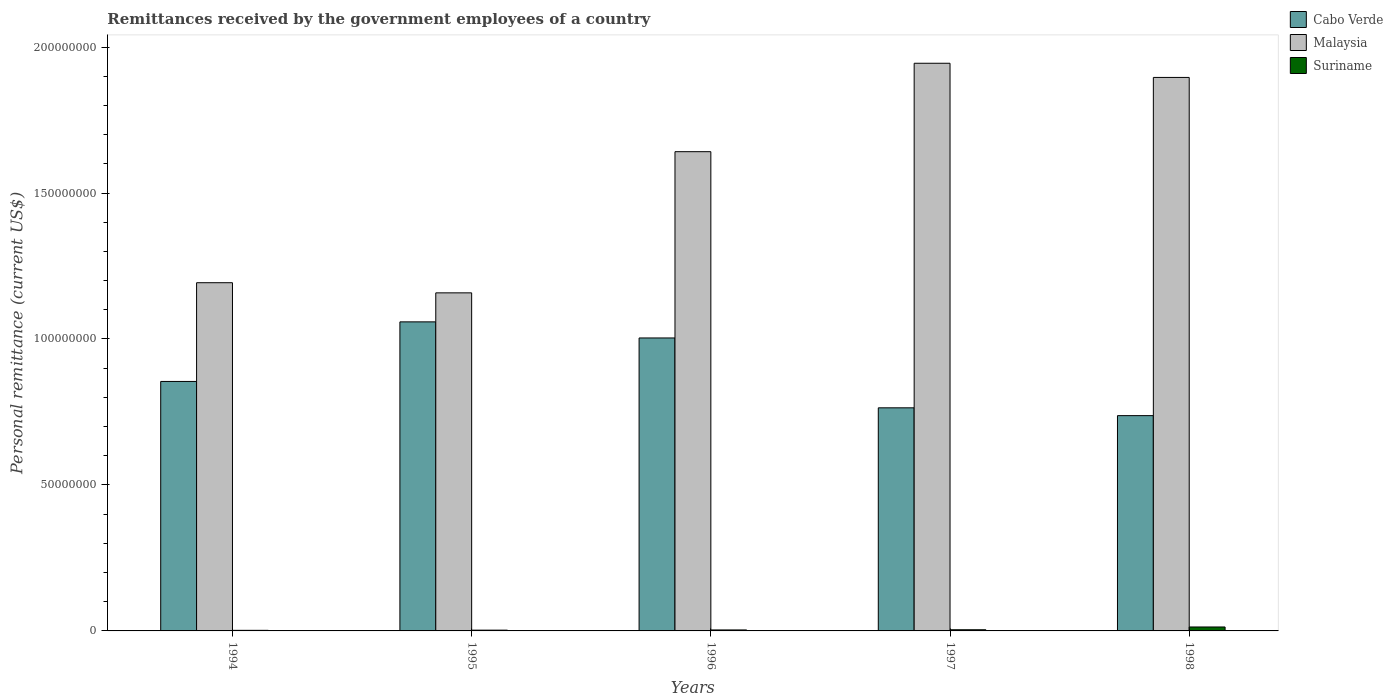How many different coloured bars are there?
Ensure brevity in your answer.  3. How many groups of bars are there?
Offer a terse response. 5. Are the number of bars per tick equal to the number of legend labels?
Provide a succinct answer. Yes. How many bars are there on the 4th tick from the right?
Your answer should be very brief. 3. What is the label of the 1st group of bars from the left?
Provide a succinct answer. 1994. In how many cases, is the number of bars for a given year not equal to the number of legend labels?
Offer a very short reply. 0. What is the remittances received by the government employees in Malaysia in 1994?
Give a very brief answer. 1.19e+08. Across all years, what is the maximum remittances received by the government employees in Malaysia?
Keep it short and to the point. 1.94e+08. Across all years, what is the minimum remittances received by the government employees in Malaysia?
Provide a succinct answer. 1.16e+08. In which year was the remittances received by the government employees in Suriname minimum?
Keep it short and to the point. 1994. What is the total remittances received by the government employees in Malaysia in the graph?
Offer a very short reply. 7.83e+08. What is the difference between the remittances received by the government employees in Cabo Verde in 1997 and that in 1998?
Provide a succinct answer. 2.68e+06. What is the difference between the remittances received by the government employees in Malaysia in 1994 and the remittances received by the government employees in Suriname in 1995?
Your answer should be very brief. 1.19e+08. What is the average remittances received by the government employees in Cabo Verde per year?
Ensure brevity in your answer.  8.84e+07. In the year 1997, what is the difference between the remittances received by the government employees in Suriname and remittances received by the government employees in Malaysia?
Keep it short and to the point. -1.94e+08. What is the ratio of the remittances received by the government employees in Cabo Verde in 1994 to that in 1995?
Give a very brief answer. 0.81. What is the difference between the highest and the second highest remittances received by the government employees in Malaysia?
Provide a succinct answer. 4.86e+06. What is the difference between the highest and the lowest remittances received by the government employees in Cabo Verde?
Provide a short and direct response. 3.21e+07. Is the sum of the remittances received by the government employees in Malaysia in 1994 and 1998 greater than the maximum remittances received by the government employees in Suriname across all years?
Ensure brevity in your answer.  Yes. What does the 2nd bar from the left in 1998 represents?
Keep it short and to the point. Malaysia. What does the 3rd bar from the right in 1997 represents?
Ensure brevity in your answer.  Cabo Verde. Is it the case that in every year, the sum of the remittances received by the government employees in Suriname and remittances received by the government employees in Malaysia is greater than the remittances received by the government employees in Cabo Verde?
Ensure brevity in your answer.  Yes. How many bars are there?
Offer a very short reply. 15. Are all the bars in the graph horizontal?
Ensure brevity in your answer.  No. How many years are there in the graph?
Offer a very short reply. 5. What is the difference between two consecutive major ticks on the Y-axis?
Provide a short and direct response. 5.00e+07. Are the values on the major ticks of Y-axis written in scientific E-notation?
Your answer should be compact. No. Does the graph contain any zero values?
Your answer should be very brief. No. How many legend labels are there?
Ensure brevity in your answer.  3. How are the legend labels stacked?
Your answer should be very brief. Vertical. What is the title of the graph?
Give a very brief answer. Remittances received by the government employees of a country. What is the label or title of the Y-axis?
Make the answer very short. Personal remittance (current US$). What is the Personal remittance (current US$) of Cabo Verde in 1994?
Your answer should be very brief. 8.55e+07. What is the Personal remittance (current US$) of Malaysia in 1994?
Your answer should be very brief. 1.19e+08. What is the Personal remittance (current US$) of Suriname in 1994?
Your response must be concise. 2.00e+05. What is the Personal remittance (current US$) of Cabo Verde in 1995?
Ensure brevity in your answer.  1.06e+08. What is the Personal remittance (current US$) of Malaysia in 1995?
Your answer should be compact. 1.16e+08. What is the Personal remittance (current US$) of Suriname in 1995?
Offer a very short reply. 2.67e+05. What is the Personal remittance (current US$) of Cabo Verde in 1996?
Offer a terse response. 1.00e+08. What is the Personal remittance (current US$) in Malaysia in 1996?
Offer a very short reply. 1.64e+08. What is the Personal remittance (current US$) of Suriname in 1996?
Offer a terse response. 3.33e+05. What is the Personal remittance (current US$) of Cabo Verde in 1997?
Ensure brevity in your answer.  7.64e+07. What is the Personal remittance (current US$) of Malaysia in 1997?
Your answer should be compact. 1.94e+08. What is the Personal remittance (current US$) in Suriname in 1997?
Make the answer very short. 4.00e+05. What is the Personal remittance (current US$) of Cabo Verde in 1998?
Provide a short and direct response. 7.37e+07. What is the Personal remittance (current US$) of Malaysia in 1998?
Give a very brief answer. 1.90e+08. What is the Personal remittance (current US$) in Suriname in 1998?
Provide a succinct answer. 1.35e+06. Across all years, what is the maximum Personal remittance (current US$) of Cabo Verde?
Offer a terse response. 1.06e+08. Across all years, what is the maximum Personal remittance (current US$) of Malaysia?
Provide a succinct answer. 1.94e+08. Across all years, what is the maximum Personal remittance (current US$) of Suriname?
Provide a short and direct response. 1.35e+06. Across all years, what is the minimum Personal remittance (current US$) of Cabo Verde?
Your answer should be compact. 7.37e+07. Across all years, what is the minimum Personal remittance (current US$) in Malaysia?
Provide a short and direct response. 1.16e+08. Across all years, what is the minimum Personal remittance (current US$) in Suriname?
Offer a very short reply. 2.00e+05. What is the total Personal remittance (current US$) of Cabo Verde in the graph?
Make the answer very short. 4.42e+08. What is the total Personal remittance (current US$) of Malaysia in the graph?
Offer a very short reply. 7.83e+08. What is the total Personal remittance (current US$) of Suriname in the graph?
Your response must be concise. 2.55e+06. What is the difference between the Personal remittance (current US$) of Cabo Verde in 1994 and that in 1995?
Give a very brief answer. -2.04e+07. What is the difference between the Personal remittance (current US$) in Malaysia in 1994 and that in 1995?
Keep it short and to the point. 3.48e+06. What is the difference between the Personal remittance (current US$) of Suriname in 1994 and that in 1995?
Keep it short and to the point. -6.67e+04. What is the difference between the Personal remittance (current US$) in Cabo Verde in 1994 and that in 1996?
Offer a very short reply. -1.49e+07. What is the difference between the Personal remittance (current US$) of Malaysia in 1994 and that in 1996?
Make the answer very short. -4.49e+07. What is the difference between the Personal remittance (current US$) in Suriname in 1994 and that in 1996?
Provide a succinct answer. -1.33e+05. What is the difference between the Personal remittance (current US$) of Cabo Verde in 1994 and that in 1997?
Provide a succinct answer. 9.04e+06. What is the difference between the Personal remittance (current US$) in Malaysia in 1994 and that in 1997?
Ensure brevity in your answer.  -7.52e+07. What is the difference between the Personal remittance (current US$) of Suriname in 1994 and that in 1997?
Provide a succinct answer. -2.00e+05. What is the difference between the Personal remittance (current US$) in Cabo Verde in 1994 and that in 1998?
Your answer should be very brief. 1.17e+07. What is the difference between the Personal remittance (current US$) in Malaysia in 1994 and that in 1998?
Give a very brief answer. -7.03e+07. What is the difference between the Personal remittance (current US$) in Suriname in 1994 and that in 1998?
Provide a succinct answer. -1.15e+06. What is the difference between the Personal remittance (current US$) of Cabo Verde in 1995 and that in 1996?
Your answer should be compact. 5.51e+06. What is the difference between the Personal remittance (current US$) in Malaysia in 1995 and that in 1996?
Provide a succinct answer. -4.84e+07. What is the difference between the Personal remittance (current US$) in Suriname in 1995 and that in 1996?
Your answer should be compact. -6.67e+04. What is the difference between the Personal remittance (current US$) in Cabo Verde in 1995 and that in 1997?
Provide a succinct answer. 2.94e+07. What is the difference between the Personal remittance (current US$) in Malaysia in 1995 and that in 1997?
Offer a terse response. -7.86e+07. What is the difference between the Personal remittance (current US$) of Suriname in 1995 and that in 1997?
Provide a succinct answer. -1.33e+05. What is the difference between the Personal remittance (current US$) of Cabo Verde in 1995 and that in 1998?
Your response must be concise. 3.21e+07. What is the difference between the Personal remittance (current US$) of Malaysia in 1995 and that in 1998?
Provide a succinct answer. -7.38e+07. What is the difference between the Personal remittance (current US$) of Suriname in 1995 and that in 1998?
Keep it short and to the point. -1.08e+06. What is the difference between the Personal remittance (current US$) in Cabo Verde in 1996 and that in 1997?
Your response must be concise. 2.39e+07. What is the difference between the Personal remittance (current US$) in Malaysia in 1996 and that in 1997?
Give a very brief answer. -3.03e+07. What is the difference between the Personal remittance (current US$) in Suriname in 1996 and that in 1997?
Your answer should be compact. -6.67e+04. What is the difference between the Personal remittance (current US$) of Cabo Verde in 1996 and that in 1998?
Provide a succinct answer. 2.66e+07. What is the difference between the Personal remittance (current US$) of Malaysia in 1996 and that in 1998?
Make the answer very short. -2.54e+07. What is the difference between the Personal remittance (current US$) in Suriname in 1996 and that in 1998?
Provide a succinct answer. -1.02e+06. What is the difference between the Personal remittance (current US$) in Cabo Verde in 1997 and that in 1998?
Offer a terse response. 2.68e+06. What is the difference between the Personal remittance (current US$) of Malaysia in 1997 and that in 1998?
Ensure brevity in your answer.  4.86e+06. What is the difference between the Personal remittance (current US$) in Suriname in 1997 and that in 1998?
Give a very brief answer. -9.50e+05. What is the difference between the Personal remittance (current US$) of Cabo Verde in 1994 and the Personal remittance (current US$) of Malaysia in 1995?
Provide a short and direct response. -3.03e+07. What is the difference between the Personal remittance (current US$) in Cabo Verde in 1994 and the Personal remittance (current US$) in Suriname in 1995?
Ensure brevity in your answer.  8.52e+07. What is the difference between the Personal remittance (current US$) of Malaysia in 1994 and the Personal remittance (current US$) of Suriname in 1995?
Keep it short and to the point. 1.19e+08. What is the difference between the Personal remittance (current US$) of Cabo Verde in 1994 and the Personal remittance (current US$) of Malaysia in 1996?
Ensure brevity in your answer.  -7.87e+07. What is the difference between the Personal remittance (current US$) of Cabo Verde in 1994 and the Personal remittance (current US$) of Suriname in 1996?
Your answer should be compact. 8.51e+07. What is the difference between the Personal remittance (current US$) of Malaysia in 1994 and the Personal remittance (current US$) of Suriname in 1996?
Your answer should be compact. 1.19e+08. What is the difference between the Personal remittance (current US$) of Cabo Verde in 1994 and the Personal remittance (current US$) of Malaysia in 1997?
Your response must be concise. -1.09e+08. What is the difference between the Personal remittance (current US$) of Cabo Verde in 1994 and the Personal remittance (current US$) of Suriname in 1997?
Your response must be concise. 8.51e+07. What is the difference between the Personal remittance (current US$) of Malaysia in 1994 and the Personal remittance (current US$) of Suriname in 1997?
Make the answer very short. 1.19e+08. What is the difference between the Personal remittance (current US$) of Cabo Verde in 1994 and the Personal remittance (current US$) of Malaysia in 1998?
Ensure brevity in your answer.  -1.04e+08. What is the difference between the Personal remittance (current US$) of Cabo Verde in 1994 and the Personal remittance (current US$) of Suriname in 1998?
Keep it short and to the point. 8.41e+07. What is the difference between the Personal remittance (current US$) of Malaysia in 1994 and the Personal remittance (current US$) of Suriname in 1998?
Provide a short and direct response. 1.18e+08. What is the difference between the Personal remittance (current US$) in Cabo Verde in 1995 and the Personal remittance (current US$) in Malaysia in 1996?
Your answer should be very brief. -5.83e+07. What is the difference between the Personal remittance (current US$) of Cabo Verde in 1995 and the Personal remittance (current US$) of Suriname in 1996?
Your response must be concise. 1.06e+08. What is the difference between the Personal remittance (current US$) in Malaysia in 1995 and the Personal remittance (current US$) in Suriname in 1996?
Ensure brevity in your answer.  1.15e+08. What is the difference between the Personal remittance (current US$) of Cabo Verde in 1995 and the Personal remittance (current US$) of Malaysia in 1997?
Offer a terse response. -8.86e+07. What is the difference between the Personal remittance (current US$) in Cabo Verde in 1995 and the Personal remittance (current US$) in Suriname in 1997?
Offer a very short reply. 1.05e+08. What is the difference between the Personal remittance (current US$) of Malaysia in 1995 and the Personal remittance (current US$) of Suriname in 1997?
Keep it short and to the point. 1.15e+08. What is the difference between the Personal remittance (current US$) of Cabo Verde in 1995 and the Personal remittance (current US$) of Malaysia in 1998?
Your response must be concise. -8.37e+07. What is the difference between the Personal remittance (current US$) of Cabo Verde in 1995 and the Personal remittance (current US$) of Suriname in 1998?
Your answer should be very brief. 1.05e+08. What is the difference between the Personal remittance (current US$) of Malaysia in 1995 and the Personal remittance (current US$) of Suriname in 1998?
Your response must be concise. 1.14e+08. What is the difference between the Personal remittance (current US$) of Cabo Verde in 1996 and the Personal remittance (current US$) of Malaysia in 1997?
Your answer should be compact. -9.41e+07. What is the difference between the Personal remittance (current US$) of Cabo Verde in 1996 and the Personal remittance (current US$) of Suriname in 1997?
Offer a very short reply. 9.99e+07. What is the difference between the Personal remittance (current US$) of Malaysia in 1996 and the Personal remittance (current US$) of Suriname in 1997?
Provide a succinct answer. 1.64e+08. What is the difference between the Personal remittance (current US$) of Cabo Verde in 1996 and the Personal remittance (current US$) of Malaysia in 1998?
Ensure brevity in your answer.  -8.92e+07. What is the difference between the Personal remittance (current US$) in Cabo Verde in 1996 and the Personal remittance (current US$) in Suriname in 1998?
Offer a very short reply. 9.90e+07. What is the difference between the Personal remittance (current US$) in Malaysia in 1996 and the Personal remittance (current US$) in Suriname in 1998?
Ensure brevity in your answer.  1.63e+08. What is the difference between the Personal remittance (current US$) of Cabo Verde in 1997 and the Personal remittance (current US$) of Malaysia in 1998?
Make the answer very short. -1.13e+08. What is the difference between the Personal remittance (current US$) of Cabo Verde in 1997 and the Personal remittance (current US$) of Suriname in 1998?
Ensure brevity in your answer.  7.51e+07. What is the difference between the Personal remittance (current US$) of Malaysia in 1997 and the Personal remittance (current US$) of Suriname in 1998?
Provide a succinct answer. 1.93e+08. What is the average Personal remittance (current US$) of Cabo Verde per year?
Your response must be concise. 8.84e+07. What is the average Personal remittance (current US$) of Malaysia per year?
Your response must be concise. 1.57e+08. What is the average Personal remittance (current US$) in Suriname per year?
Offer a very short reply. 5.10e+05. In the year 1994, what is the difference between the Personal remittance (current US$) of Cabo Verde and Personal remittance (current US$) of Malaysia?
Ensure brevity in your answer.  -3.38e+07. In the year 1994, what is the difference between the Personal remittance (current US$) in Cabo Verde and Personal remittance (current US$) in Suriname?
Keep it short and to the point. 8.53e+07. In the year 1994, what is the difference between the Personal remittance (current US$) in Malaysia and Personal remittance (current US$) in Suriname?
Keep it short and to the point. 1.19e+08. In the year 1995, what is the difference between the Personal remittance (current US$) in Cabo Verde and Personal remittance (current US$) in Malaysia?
Your answer should be very brief. -9.94e+06. In the year 1995, what is the difference between the Personal remittance (current US$) of Cabo Verde and Personal remittance (current US$) of Suriname?
Provide a succinct answer. 1.06e+08. In the year 1995, what is the difference between the Personal remittance (current US$) of Malaysia and Personal remittance (current US$) of Suriname?
Keep it short and to the point. 1.16e+08. In the year 1996, what is the difference between the Personal remittance (current US$) of Cabo Verde and Personal remittance (current US$) of Malaysia?
Your response must be concise. -6.38e+07. In the year 1996, what is the difference between the Personal remittance (current US$) of Cabo Verde and Personal remittance (current US$) of Suriname?
Your response must be concise. 1.00e+08. In the year 1996, what is the difference between the Personal remittance (current US$) of Malaysia and Personal remittance (current US$) of Suriname?
Ensure brevity in your answer.  1.64e+08. In the year 1997, what is the difference between the Personal remittance (current US$) of Cabo Verde and Personal remittance (current US$) of Malaysia?
Make the answer very short. -1.18e+08. In the year 1997, what is the difference between the Personal remittance (current US$) in Cabo Verde and Personal remittance (current US$) in Suriname?
Provide a succinct answer. 7.60e+07. In the year 1997, what is the difference between the Personal remittance (current US$) of Malaysia and Personal remittance (current US$) of Suriname?
Offer a very short reply. 1.94e+08. In the year 1998, what is the difference between the Personal remittance (current US$) of Cabo Verde and Personal remittance (current US$) of Malaysia?
Provide a succinct answer. -1.16e+08. In the year 1998, what is the difference between the Personal remittance (current US$) of Cabo Verde and Personal remittance (current US$) of Suriname?
Ensure brevity in your answer.  7.24e+07. In the year 1998, what is the difference between the Personal remittance (current US$) of Malaysia and Personal remittance (current US$) of Suriname?
Keep it short and to the point. 1.88e+08. What is the ratio of the Personal remittance (current US$) in Cabo Verde in 1994 to that in 1995?
Provide a short and direct response. 0.81. What is the ratio of the Personal remittance (current US$) of Suriname in 1994 to that in 1995?
Offer a very short reply. 0.75. What is the ratio of the Personal remittance (current US$) of Cabo Verde in 1994 to that in 1996?
Ensure brevity in your answer.  0.85. What is the ratio of the Personal remittance (current US$) in Malaysia in 1994 to that in 1996?
Provide a short and direct response. 0.73. What is the ratio of the Personal remittance (current US$) of Cabo Verde in 1994 to that in 1997?
Offer a very short reply. 1.12. What is the ratio of the Personal remittance (current US$) of Malaysia in 1994 to that in 1997?
Make the answer very short. 0.61. What is the ratio of the Personal remittance (current US$) of Cabo Verde in 1994 to that in 1998?
Offer a terse response. 1.16. What is the ratio of the Personal remittance (current US$) of Malaysia in 1994 to that in 1998?
Keep it short and to the point. 0.63. What is the ratio of the Personal remittance (current US$) in Suriname in 1994 to that in 1998?
Ensure brevity in your answer.  0.15. What is the ratio of the Personal remittance (current US$) in Cabo Verde in 1995 to that in 1996?
Offer a very short reply. 1.05. What is the ratio of the Personal remittance (current US$) of Malaysia in 1995 to that in 1996?
Offer a terse response. 0.71. What is the ratio of the Personal remittance (current US$) in Suriname in 1995 to that in 1996?
Make the answer very short. 0.8. What is the ratio of the Personal remittance (current US$) of Cabo Verde in 1995 to that in 1997?
Offer a terse response. 1.39. What is the ratio of the Personal remittance (current US$) of Malaysia in 1995 to that in 1997?
Provide a short and direct response. 0.6. What is the ratio of the Personal remittance (current US$) of Cabo Verde in 1995 to that in 1998?
Your answer should be very brief. 1.44. What is the ratio of the Personal remittance (current US$) of Malaysia in 1995 to that in 1998?
Offer a very short reply. 0.61. What is the ratio of the Personal remittance (current US$) of Suriname in 1995 to that in 1998?
Ensure brevity in your answer.  0.2. What is the ratio of the Personal remittance (current US$) in Cabo Verde in 1996 to that in 1997?
Ensure brevity in your answer.  1.31. What is the ratio of the Personal remittance (current US$) of Malaysia in 1996 to that in 1997?
Give a very brief answer. 0.84. What is the ratio of the Personal remittance (current US$) of Cabo Verde in 1996 to that in 1998?
Ensure brevity in your answer.  1.36. What is the ratio of the Personal remittance (current US$) of Malaysia in 1996 to that in 1998?
Provide a short and direct response. 0.87. What is the ratio of the Personal remittance (current US$) in Suriname in 1996 to that in 1998?
Offer a very short reply. 0.25. What is the ratio of the Personal remittance (current US$) in Cabo Verde in 1997 to that in 1998?
Provide a short and direct response. 1.04. What is the ratio of the Personal remittance (current US$) in Malaysia in 1997 to that in 1998?
Provide a succinct answer. 1.03. What is the ratio of the Personal remittance (current US$) of Suriname in 1997 to that in 1998?
Make the answer very short. 0.3. What is the difference between the highest and the second highest Personal remittance (current US$) in Cabo Verde?
Provide a short and direct response. 5.51e+06. What is the difference between the highest and the second highest Personal remittance (current US$) in Malaysia?
Your response must be concise. 4.86e+06. What is the difference between the highest and the second highest Personal remittance (current US$) of Suriname?
Your answer should be very brief. 9.50e+05. What is the difference between the highest and the lowest Personal remittance (current US$) in Cabo Verde?
Offer a terse response. 3.21e+07. What is the difference between the highest and the lowest Personal remittance (current US$) of Malaysia?
Your answer should be compact. 7.86e+07. What is the difference between the highest and the lowest Personal remittance (current US$) in Suriname?
Your answer should be very brief. 1.15e+06. 